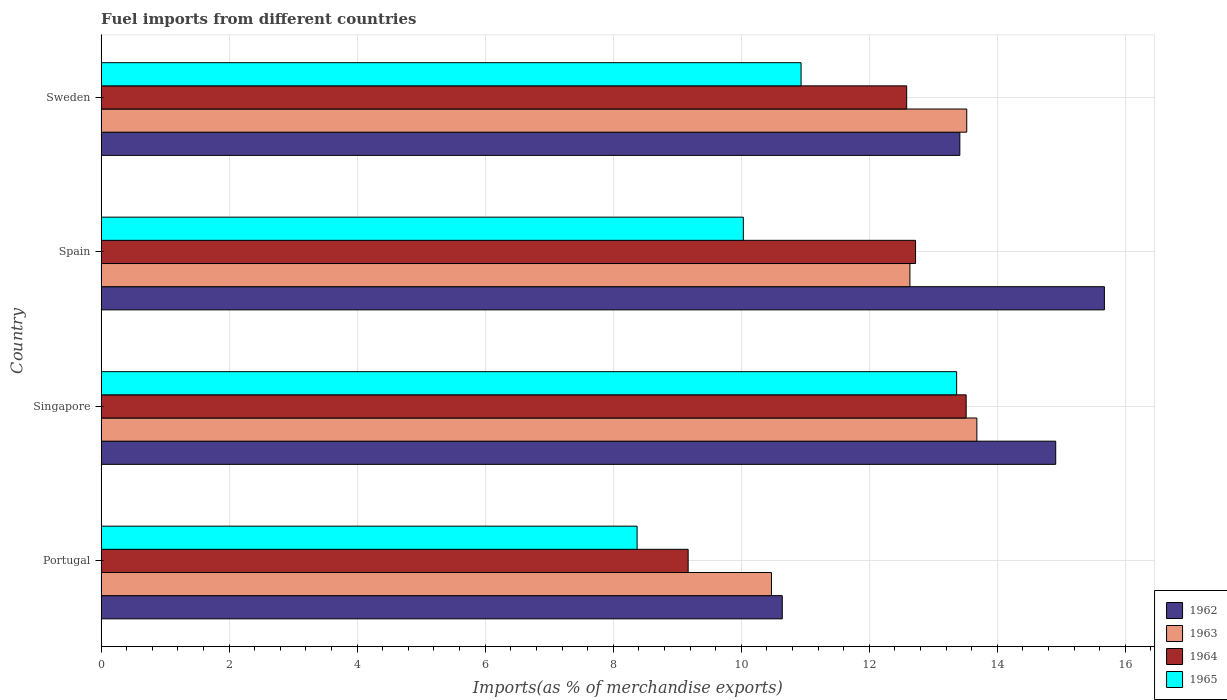Are the number of bars per tick equal to the number of legend labels?
Your answer should be very brief. Yes. How many bars are there on the 4th tick from the top?
Keep it short and to the point. 4. What is the label of the 4th group of bars from the top?
Keep it short and to the point. Portugal. What is the percentage of imports to different countries in 1964 in Spain?
Your answer should be compact. 12.72. Across all countries, what is the maximum percentage of imports to different countries in 1963?
Your response must be concise. 13.68. Across all countries, what is the minimum percentage of imports to different countries in 1962?
Provide a short and direct response. 10.64. In which country was the percentage of imports to different countries in 1963 maximum?
Provide a short and direct response. Singapore. In which country was the percentage of imports to different countries in 1965 minimum?
Give a very brief answer. Portugal. What is the total percentage of imports to different countries in 1962 in the graph?
Offer a terse response. 54.64. What is the difference between the percentage of imports to different countries in 1963 in Spain and that in Sweden?
Ensure brevity in your answer.  -0.89. What is the difference between the percentage of imports to different countries in 1965 in Portugal and the percentage of imports to different countries in 1963 in Sweden?
Make the answer very short. -5.15. What is the average percentage of imports to different countries in 1965 per country?
Offer a terse response. 10.68. What is the difference between the percentage of imports to different countries in 1964 and percentage of imports to different countries in 1963 in Sweden?
Your answer should be compact. -0.94. What is the ratio of the percentage of imports to different countries in 1964 in Portugal to that in Sweden?
Offer a very short reply. 0.73. Is the percentage of imports to different countries in 1962 in Singapore less than that in Spain?
Provide a succinct answer. Yes. Is the difference between the percentage of imports to different countries in 1964 in Singapore and Sweden greater than the difference between the percentage of imports to different countries in 1963 in Singapore and Sweden?
Make the answer very short. Yes. What is the difference between the highest and the second highest percentage of imports to different countries in 1965?
Provide a succinct answer. 2.43. What is the difference between the highest and the lowest percentage of imports to different countries in 1962?
Provide a succinct answer. 5.03. In how many countries, is the percentage of imports to different countries in 1965 greater than the average percentage of imports to different countries in 1965 taken over all countries?
Ensure brevity in your answer.  2. Is the sum of the percentage of imports to different countries in 1963 in Portugal and Singapore greater than the maximum percentage of imports to different countries in 1965 across all countries?
Your answer should be compact. Yes. What does the 1st bar from the top in Singapore represents?
Your answer should be compact. 1965. What does the 2nd bar from the bottom in Singapore represents?
Offer a terse response. 1963. Is it the case that in every country, the sum of the percentage of imports to different countries in 1963 and percentage of imports to different countries in 1965 is greater than the percentage of imports to different countries in 1962?
Ensure brevity in your answer.  Yes. What is the difference between two consecutive major ticks on the X-axis?
Provide a succinct answer. 2. Does the graph contain grids?
Offer a terse response. Yes. Where does the legend appear in the graph?
Provide a short and direct response. Bottom right. How are the legend labels stacked?
Make the answer very short. Vertical. What is the title of the graph?
Make the answer very short. Fuel imports from different countries. What is the label or title of the X-axis?
Ensure brevity in your answer.  Imports(as % of merchandise exports). What is the label or title of the Y-axis?
Your answer should be very brief. Country. What is the Imports(as % of merchandise exports) of 1962 in Portugal?
Keep it short and to the point. 10.64. What is the Imports(as % of merchandise exports) in 1963 in Portugal?
Make the answer very short. 10.47. What is the Imports(as % of merchandise exports) in 1964 in Portugal?
Ensure brevity in your answer.  9.17. What is the Imports(as % of merchandise exports) of 1965 in Portugal?
Your answer should be compact. 8.37. What is the Imports(as % of merchandise exports) of 1962 in Singapore?
Offer a very short reply. 14.91. What is the Imports(as % of merchandise exports) in 1963 in Singapore?
Your response must be concise. 13.68. What is the Imports(as % of merchandise exports) of 1964 in Singapore?
Make the answer very short. 13.51. What is the Imports(as % of merchandise exports) in 1965 in Singapore?
Provide a short and direct response. 13.37. What is the Imports(as % of merchandise exports) of 1962 in Spain?
Ensure brevity in your answer.  15.67. What is the Imports(as % of merchandise exports) of 1963 in Spain?
Your answer should be very brief. 12.64. What is the Imports(as % of merchandise exports) in 1964 in Spain?
Offer a terse response. 12.72. What is the Imports(as % of merchandise exports) of 1965 in Spain?
Make the answer very short. 10.03. What is the Imports(as % of merchandise exports) of 1962 in Sweden?
Provide a succinct answer. 13.42. What is the Imports(as % of merchandise exports) of 1963 in Sweden?
Provide a succinct answer. 13.52. What is the Imports(as % of merchandise exports) in 1964 in Sweden?
Your answer should be very brief. 12.58. What is the Imports(as % of merchandise exports) of 1965 in Sweden?
Offer a terse response. 10.93. Across all countries, what is the maximum Imports(as % of merchandise exports) in 1962?
Provide a short and direct response. 15.67. Across all countries, what is the maximum Imports(as % of merchandise exports) in 1963?
Keep it short and to the point. 13.68. Across all countries, what is the maximum Imports(as % of merchandise exports) in 1964?
Give a very brief answer. 13.51. Across all countries, what is the maximum Imports(as % of merchandise exports) in 1965?
Your answer should be compact. 13.37. Across all countries, what is the minimum Imports(as % of merchandise exports) of 1962?
Offer a very short reply. 10.64. Across all countries, what is the minimum Imports(as % of merchandise exports) in 1963?
Keep it short and to the point. 10.47. Across all countries, what is the minimum Imports(as % of merchandise exports) of 1964?
Keep it short and to the point. 9.17. Across all countries, what is the minimum Imports(as % of merchandise exports) in 1965?
Ensure brevity in your answer.  8.37. What is the total Imports(as % of merchandise exports) of 1962 in the graph?
Your answer should be very brief. 54.64. What is the total Imports(as % of merchandise exports) in 1963 in the graph?
Keep it short and to the point. 50.31. What is the total Imports(as % of merchandise exports) in 1964 in the graph?
Ensure brevity in your answer.  47.99. What is the total Imports(as % of merchandise exports) in 1965 in the graph?
Ensure brevity in your answer.  42.71. What is the difference between the Imports(as % of merchandise exports) of 1962 in Portugal and that in Singapore?
Provide a succinct answer. -4.27. What is the difference between the Imports(as % of merchandise exports) of 1963 in Portugal and that in Singapore?
Keep it short and to the point. -3.21. What is the difference between the Imports(as % of merchandise exports) of 1964 in Portugal and that in Singapore?
Your answer should be very brief. -4.34. What is the difference between the Imports(as % of merchandise exports) of 1965 in Portugal and that in Singapore?
Ensure brevity in your answer.  -4.99. What is the difference between the Imports(as % of merchandise exports) in 1962 in Portugal and that in Spain?
Ensure brevity in your answer.  -5.03. What is the difference between the Imports(as % of merchandise exports) of 1963 in Portugal and that in Spain?
Your answer should be very brief. -2.16. What is the difference between the Imports(as % of merchandise exports) of 1964 in Portugal and that in Spain?
Keep it short and to the point. -3.55. What is the difference between the Imports(as % of merchandise exports) of 1965 in Portugal and that in Spain?
Your answer should be very brief. -1.66. What is the difference between the Imports(as % of merchandise exports) in 1962 in Portugal and that in Sweden?
Offer a terse response. -2.77. What is the difference between the Imports(as % of merchandise exports) in 1963 in Portugal and that in Sweden?
Provide a short and direct response. -3.05. What is the difference between the Imports(as % of merchandise exports) of 1964 in Portugal and that in Sweden?
Make the answer very short. -3.41. What is the difference between the Imports(as % of merchandise exports) in 1965 in Portugal and that in Sweden?
Make the answer very short. -2.56. What is the difference between the Imports(as % of merchandise exports) in 1962 in Singapore and that in Spain?
Offer a very short reply. -0.76. What is the difference between the Imports(as % of merchandise exports) of 1963 in Singapore and that in Spain?
Make the answer very short. 1.05. What is the difference between the Imports(as % of merchandise exports) of 1964 in Singapore and that in Spain?
Your answer should be very brief. 0.79. What is the difference between the Imports(as % of merchandise exports) in 1965 in Singapore and that in Spain?
Your response must be concise. 3.33. What is the difference between the Imports(as % of merchandise exports) of 1962 in Singapore and that in Sweden?
Keep it short and to the point. 1.5. What is the difference between the Imports(as % of merchandise exports) of 1963 in Singapore and that in Sweden?
Your response must be concise. 0.16. What is the difference between the Imports(as % of merchandise exports) in 1964 in Singapore and that in Sweden?
Your answer should be very brief. 0.93. What is the difference between the Imports(as % of merchandise exports) in 1965 in Singapore and that in Sweden?
Provide a short and direct response. 2.43. What is the difference between the Imports(as % of merchandise exports) in 1962 in Spain and that in Sweden?
Provide a succinct answer. 2.26. What is the difference between the Imports(as % of merchandise exports) of 1963 in Spain and that in Sweden?
Keep it short and to the point. -0.89. What is the difference between the Imports(as % of merchandise exports) of 1964 in Spain and that in Sweden?
Make the answer very short. 0.14. What is the difference between the Imports(as % of merchandise exports) of 1965 in Spain and that in Sweden?
Offer a terse response. -0.9. What is the difference between the Imports(as % of merchandise exports) in 1962 in Portugal and the Imports(as % of merchandise exports) in 1963 in Singapore?
Provide a short and direct response. -3.04. What is the difference between the Imports(as % of merchandise exports) in 1962 in Portugal and the Imports(as % of merchandise exports) in 1964 in Singapore?
Your response must be concise. -2.87. What is the difference between the Imports(as % of merchandise exports) in 1962 in Portugal and the Imports(as % of merchandise exports) in 1965 in Singapore?
Your answer should be compact. -2.72. What is the difference between the Imports(as % of merchandise exports) of 1963 in Portugal and the Imports(as % of merchandise exports) of 1964 in Singapore?
Offer a terse response. -3.04. What is the difference between the Imports(as % of merchandise exports) in 1963 in Portugal and the Imports(as % of merchandise exports) in 1965 in Singapore?
Keep it short and to the point. -2.89. What is the difference between the Imports(as % of merchandise exports) in 1964 in Portugal and the Imports(as % of merchandise exports) in 1965 in Singapore?
Give a very brief answer. -4.19. What is the difference between the Imports(as % of merchandise exports) in 1962 in Portugal and the Imports(as % of merchandise exports) in 1963 in Spain?
Offer a very short reply. -1.99. What is the difference between the Imports(as % of merchandise exports) of 1962 in Portugal and the Imports(as % of merchandise exports) of 1964 in Spain?
Offer a very short reply. -2.08. What is the difference between the Imports(as % of merchandise exports) of 1962 in Portugal and the Imports(as % of merchandise exports) of 1965 in Spain?
Give a very brief answer. 0.61. What is the difference between the Imports(as % of merchandise exports) of 1963 in Portugal and the Imports(as % of merchandise exports) of 1964 in Spain?
Offer a very short reply. -2.25. What is the difference between the Imports(as % of merchandise exports) in 1963 in Portugal and the Imports(as % of merchandise exports) in 1965 in Spain?
Offer a terse response. 0.44. What is the difference between the Imports(as % of merchandise exports) of 1964 in Portugal and the Imports(as % of merchandise exports) of 1965 in Spain?
Ensure brevity in your answer.  -0.86. What is the difference between the Imports(as % of merchandise exports) in 1962 in Portugal and the Imports(as % of merchandise exports) in 1963 in Sweden?
Your answer should be very brief. -2.88. What is the difference between the Imports(as % of merchandise exports) of 1962 in Portugal and the Imports(as % of merchandise exports) of 1964 in Sweden?
Offer a terse response. -1.94. What is the difference between the Imports(as % of merchandise exports) of 1962 in Portugal and the Imports(as % of merchandise exports) of 1965 in Sweden?
Make the answer very short. -0.29. What is the difference between the Imports(as % of merchandise exports) of 1963 in Portugal and the Imports(as % of merchandise exports) of 1964 in Sweden?
Provide a succinct answer. -2.11. What is the difference between the Imports(as % of merchandise exports) of 1963 in Portugal and the Imports(as % of merchandise exports) of 1965 in Sweden?
Ensure brevity in your answer.  -0.46. What is the difference between the Imports(as % of merchandise exports) of 1964 in Portugal and the Imports(as % of merchandise exports) of 1965 in Sweden?
Make the answer very short. -1.76. What is the difference between the Imports(as % of merchandise exports) of 1962 in Singapore and the Imports(as % of merchandise exports) of 1963 in Spain?
Your response must be concise. 2.28. What is the difference between the Imports(as % of merchandise exports) of 1962 in Singapore and the Imports(as % of merchandise exports) of 1964 in Spain?
Provide a succinct answer. 2.19. What is the difference between the Imports(as % of merchandise exports) of 1962 in Singapore and the Imports(as % of merchandise exports) of 1965 in Spain?
Ensure brevity in your answer.  4.88. What is the difference between the Imports(as % of merchandise exports) in 1963 in Singapore and the Imports(as % of merchandise exports) in 1964 in Spain?
Ensure brevity in your answer.  0.96. What is the difference between the Imports(as % of merchandise exports) in 1963 in Singapore and the Imports(as % of merchandise exports) in 1965 in Spain?
Your response must be concise. 3.65. What is the difference between the Imports(as % of merchandise exports) in 1964 in Singapore and the Imports(as % of merchandise exports) in 1965 in Spain?
Offer a terse response. 3.48. What is the difference between the Imports(as % of merchandise exports) in 1962 in Singapore and the Imports(as % of merchandise exports) in 1963 in Sweden?
Your answer should be very brief. 1.39. What is the difference between the Imports(as % of merchandise exports) of 1962 in Singapore and the Imports(as % of merchandise exports) of 1964 in Sweden?
Provide a short and direct response. 2.33. What is the difference between the Imports(as % of merchandise exports) in 1962 in Singapore and the Imports(as % of merchandise exports) in 1965 in Sweden?
Give a very brief answer. 3.98. What is the difference between the Imports(as % of merchandise exports) of 1963 in Singapore and the Imports(as % of merchandise exports) of 1964 in Sweden?
Your answer should be compact. 1.1. What is the difference between the Imports(as % of merchandise exports) of 1963 in Singapore and the Imports(as % of merchandise exports) of 1965 in Sweden?
Provide a succinct answer. 2.75. What is the difference between the Imports(as % of merchandise exports) in 1964 in Singapore and the Imports(as % of merchandise exports) in 1965 in Sweden?
Your response must be concise. 2.58. What is the difference between the Imports(as % of merchandise exports) of 1962 in Spain and the Imports(as % of merchandise exports) of 1963 in Sweden?
Offer a terse response. 2.15. What is the difference between the Imports(as % of merchandise exports) of 1962 in Spain and the Imports(as % of merchandise exports) of 1964 in Sweden?
Ensure brevity in your answer.  3.09. What is the difference between the Imports(as % of merchandise exports) of 1962 in Spain and the Imports(as % of merchandise exports) of 1965 in Sweden?
Your answer should be very brief. 4.74. What is the difference between the Imports(as % of merchandise exports) of 1963 in Spain and the Imports(as % of merchandise exports) of 1964 in Sweden?
Ensure brevity in your answer.  0.05. What is the difference between the Imports(as % of merchandise exports) of 1963 in Spain and the Imports(as % of merchandise exports) of 1965 in Sweden?
Give a very brief answer. 1.7. What is the difference between the Imports(as % of merchandise exports) in 1964 in Spain and the Imports(as % of merchandise exports) in 1965 in Sweden?
Ensure brevity in your answer.  1.79. What is the average Imports(as % of merchandise exports) of 1962 per country?
Make the answer very short. 13.66. What is the average Imports(as % of merchandise exports) in 1963 per country?
Offer a very short reply. 12.58. What is the average Imports(as % of merchandise exports) in 1964 per country?
Your answer should be compact. 12. What is the average Imports(as % of merchandise exports) in 1965 per country?
Your answer should be compact. 10.68. What is the difference between the Imports(as % of merchandise exports) of 1962 and Imports(as % of merchandise exports) of 1963 in Portugal?
Your response must be concise. 0.17. What is the difference between the Imports(as % of merchandise exports) of 1962 and Imports(as % of merchandise exports) of 1964 in Portugal?
Provide a succinct answer. 1.47. What is the difference between the Imports(as % of merchandise exports) of 1962 and Imports(as % of merchandise exports) of 1965 in Portugal?
Your response must be concise. 2.27. What is the difference between the Imports(as % of merchandise exports) of 1963 and Imports(as % of merchandise exports) of 1964 in Portugal?
Provide a short and direct response. 1.3. What is the difference between the Imports(as % of merchandise exports) of 1963 and Imports(as % of merchandise exports) of 1965 in Portugal?
Your response must be concise. 2.1. What is the difference between the Imports(as % of merchandise exports) of 1964 and Imports(as % of merchandise exports) of 1965 in Portugal?
Provide a short and direct response. 0.8. What is the difference between the Imports(as % of merchandise exports) in 1962 and Imports(as % of merchandise exports) in 1963 in Singapore?
Provide a succinct answer. 1.23. What is the difference between the Imports(as % of merchandise exports) of 1962 and Imports(as % of merchandise exports) of 1964 in Singapore?
Make the answer very short. 1.4. What is the difference between the Imports(as % of merchandise exports) in 1962 and Imports(as % of merchandise exports) in 1965 in Singapore?
Keep it short and to the point. 1.55. What is the difference between the Imports(as % of merchandise exports) in 1963 and Imports(as % of merchandise exports) in 1964 in Singapore?
Your response must be concise. 0.17. What is the difference between the Imports(as % of merchandise exports) in 1963 and Imports(as % of merchandise exports) in 1965 in Singapore?
Make the answer very short. 0.32. What is the difference between the Imports(as % of merchandise exports) of 1964 and Imports(as % of merchandise exports) of 1965 in Singapore?
Ensure brevity in your answer.  0.15. What is the difference between the Imports(as % of merchandise exports) of 1962 and Imports(as % of merchandise exports) of 1963 in Spain?
Offer a very short reply. 3.04. What is the difference between the Imports(as % of merchandise exports) in 1962 and Imports(as % of merchandise exports) in 1964 in Spain?
Ensure brevity in your answer.  2.95. What is the difference between the Imports(as % of merchandise exports) of 1962 and Imports(as % of merchandise exports) of 1965 in Spain?
Keep it short and to the point. 5.64. What is the difference between the Imports(as % of merchandise exports) of 1963 and Imports(as % of merchandise exports) of 1964 in Spain?
Make the answer very short. -0.09. What is the difference between the Imports(as % of merchandise exports) in 1963 and Imports(as % of merchandise exports) in 1965 in Spain?
Provide a short and direct response. 2.6. What is the difference between the Imports(as % of merchandise exports) in 1964 and Imports(as % of merchandise exports) in 1965 in Spain?
Provide a short and direct response. 2.69. What is the difference between the Imports(as % of merchandise exports) of 1962 and Imports(as % of merchandise exports) of 1963 in Sweden?
Your response must be concise. -0.11. What is the difference between the Imports(as % of merchandise exports) in 1962 and Imports(as % of merchandise exports) in 1964 in Sweden?
Your answer should be very brief. 0.83. What is the difference between the Imports(as % of merchandise exports) of 1962 and Imports(as % of merchandise exports) of 1965 in Sweden?
Your answer should be very brief. 2.48. What is the difference between the Imports(as % of merchandise exports) in 1963 and Imports(as % of merchandise exports) in 1964 in Sweden?
Offer a terse response. 0.94. What is the difference between the Imports(as % of merchandise exports) of 1963 and Imports(as % of merchandise exports) of 1965 in Sweden?
Ensure brevity in your answer.  2.59. What is the difference between the Imports(as % of merchandise exports) of 1964 and Imports(as % of merchandise exports) of 1965 in Sweden?
Make the answer very short. 1.65. What is the ratio of the Imports(as % of merchandise exports) in 1962 in Portugal to that in Singapore?
Offer a very short reply. 0.71. What is the ratio of the Imports(as % of merchandise exports) of 1963 in Portugal to that in Singapore?
Keep it short and to the point. 0.77. What is the ratio of the Imports(as % of merchandise exports) in 1964 in Portugal to that in Singapore?
Offer a very short reply. 0.68. What is the ratio of the Imports(as % of merchandise exports) in 1965 in Portugal to that in Singapore?
Make the answer very short. 0.63. What is the ratio of the Imports(as % of merchandise exports) in 1962 in Portugal to that in Spain?
Keep it short and to the point. 0.68. What is the ratio of the Imports(as % of merchandise exports) in 1963 in Portugal to that in Spain?
Your answer should be very brief. 0.83. What is the ratio of the Imports(as % of merchandise exports) of 1964 in Portugal to that in Spain?
Your answer should be compact. 0.72. What is the ratio of the Imports(as % of merchandise exports) in 1965 in Portugal to that in Spain?
Ensure brevity in your answer.  0.83. What is the ratio of the Imports(as % of merchandise exports) of 1962 in Portugal to that in Sweden?
Ensure brevity in your answer.  0.79. What is the ratio of the Imports(as % of merchandise exports) of 1963 in Portugal to that in Sweden?
Your answer should be very brief. 0.77. What is the ratio of the Imports(as % of merchandise exports) of 1964 in Portugal to that in Sweden?
Ensure brevity in your answer.  0.73. What is the ratio of the Imports(as % of merchandise exports) of 1965 in Portugal to that in Sweden?
Provide a succinct answer. 0.77. What is the ratio of the Imports(as % of merchandise exports) in 1962 in Singapore to that in Spain?
Provide a succinct answer. 0.95. What is the ratio of the Imports(as % of merchandise exports) in 1963 in Singapore to that in Spain?
Your answer should be compact. 1.08. What is the ratio of the Imports(as % of merchandise exports) of 1964 in Singapore to that in Spain?
Your response must be concise. 1.06. What is the ratio of the Imports(as % of merchandise exports) of 1965 in Singapore to that in Spain?
Provide a short and direct response. 1.33. What is the ratio of the Imports(as % of merchandise exports) in 1962 in Singapore to that in Sweden?
Ensure brevity in your answer.  1.11. What is the ratio of the Imports(as % of merchandise exports) of 1963 in Singapore to that in Sweden?
Give a very brief answer. 1.01. What is the ratio of the Imports(as % of merchandise exports) in 1964 in Singapore to that in Sweden?
Your response must be concise. 1.07. What is the ratio of the Imports(as % of merchandise exports) of 1965 in Singapore to that in Sweden?
Your answer should be very brief. 1.22. What is the ratio of the Imports(as % of merchandise exports) in 1962 in Spain to that in Sweden?
Your answer should be very brief. 1.17. What is the ratio of the Imports(as % of merchandise exports) of 1963 in Spain to that in Sweden?
Keep it short and to the point. 0.93. What is the ratio of the Imports(as % of merchandise exports) of 1965 in Spain to that in Sweden?
Your answer should be very brief. 0.92. What is the difference between the highest and the second highest Imports(as % of merchandise exports) of 1962?
Offer a very short reply. 0.76. What is the difference between the highest and the second highest Imports(as % of merchandise exports) of 1963?
Provide a succinct answer. 0.16. What is the difference between the highest and the second highest Imports(as % of merchandise exports) in 1964?
Ensure brevity in your answer.  0.79. What is the difference between the highest and the second highest Imports(as % of merchandise exports) in 1965?
Your answer should be very brief. 2.43. What is the difference between the highest and the lowest Imports(as % of merchandise exports) in 1962?
Make the answer very short. 5.03. What is the difference between the highest and the lowest Imports(as % of merchandise exports) in 1963?
Keep it short and to the point. 3.21. What is the difference between the highest and the lowest Imports(as % of merchandise exports) of 1964?
Provide a short and direct response. 4.34. What is the difference between the highest and the lowest Imports(as % of merchandise exports) of 1965?
Give a very brief answer. 4.99. 